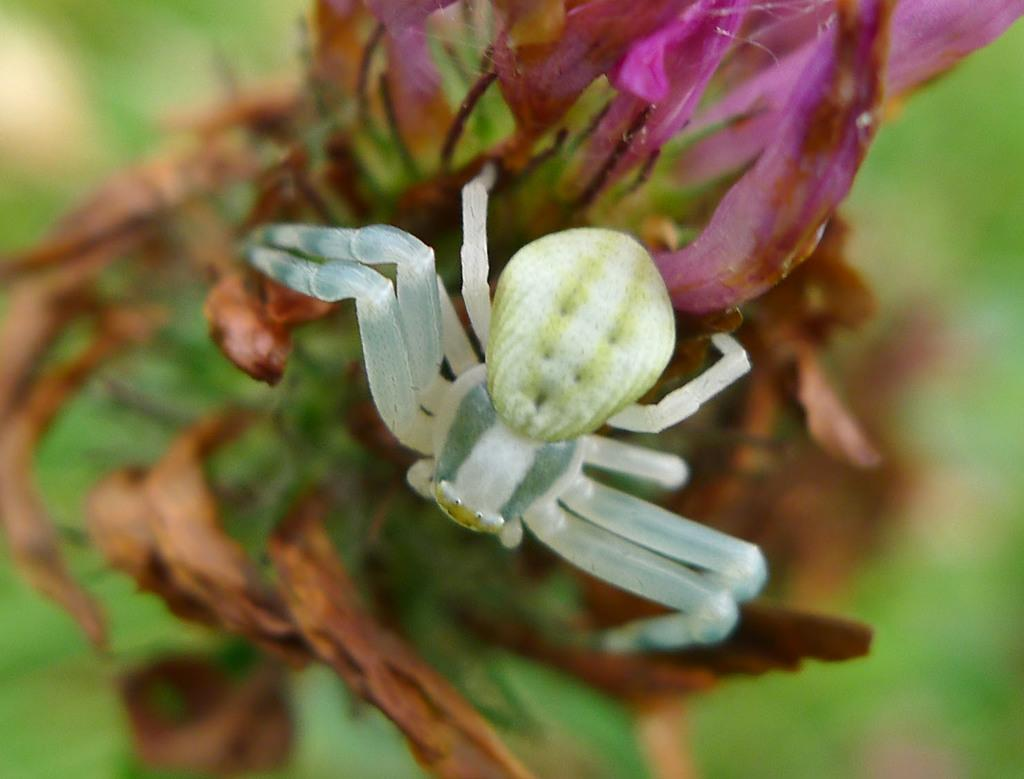What type of living organism can be seen in the image? There is an insect in the image. What plant is visible in the image? There is a flower in the image. Can you describe the background of the image? The background of the image is blurry. What type of sponge is being used to clean the blood in the image? There is no sponge or blood present in the image; it features an insect and a flower with a blurry background. 